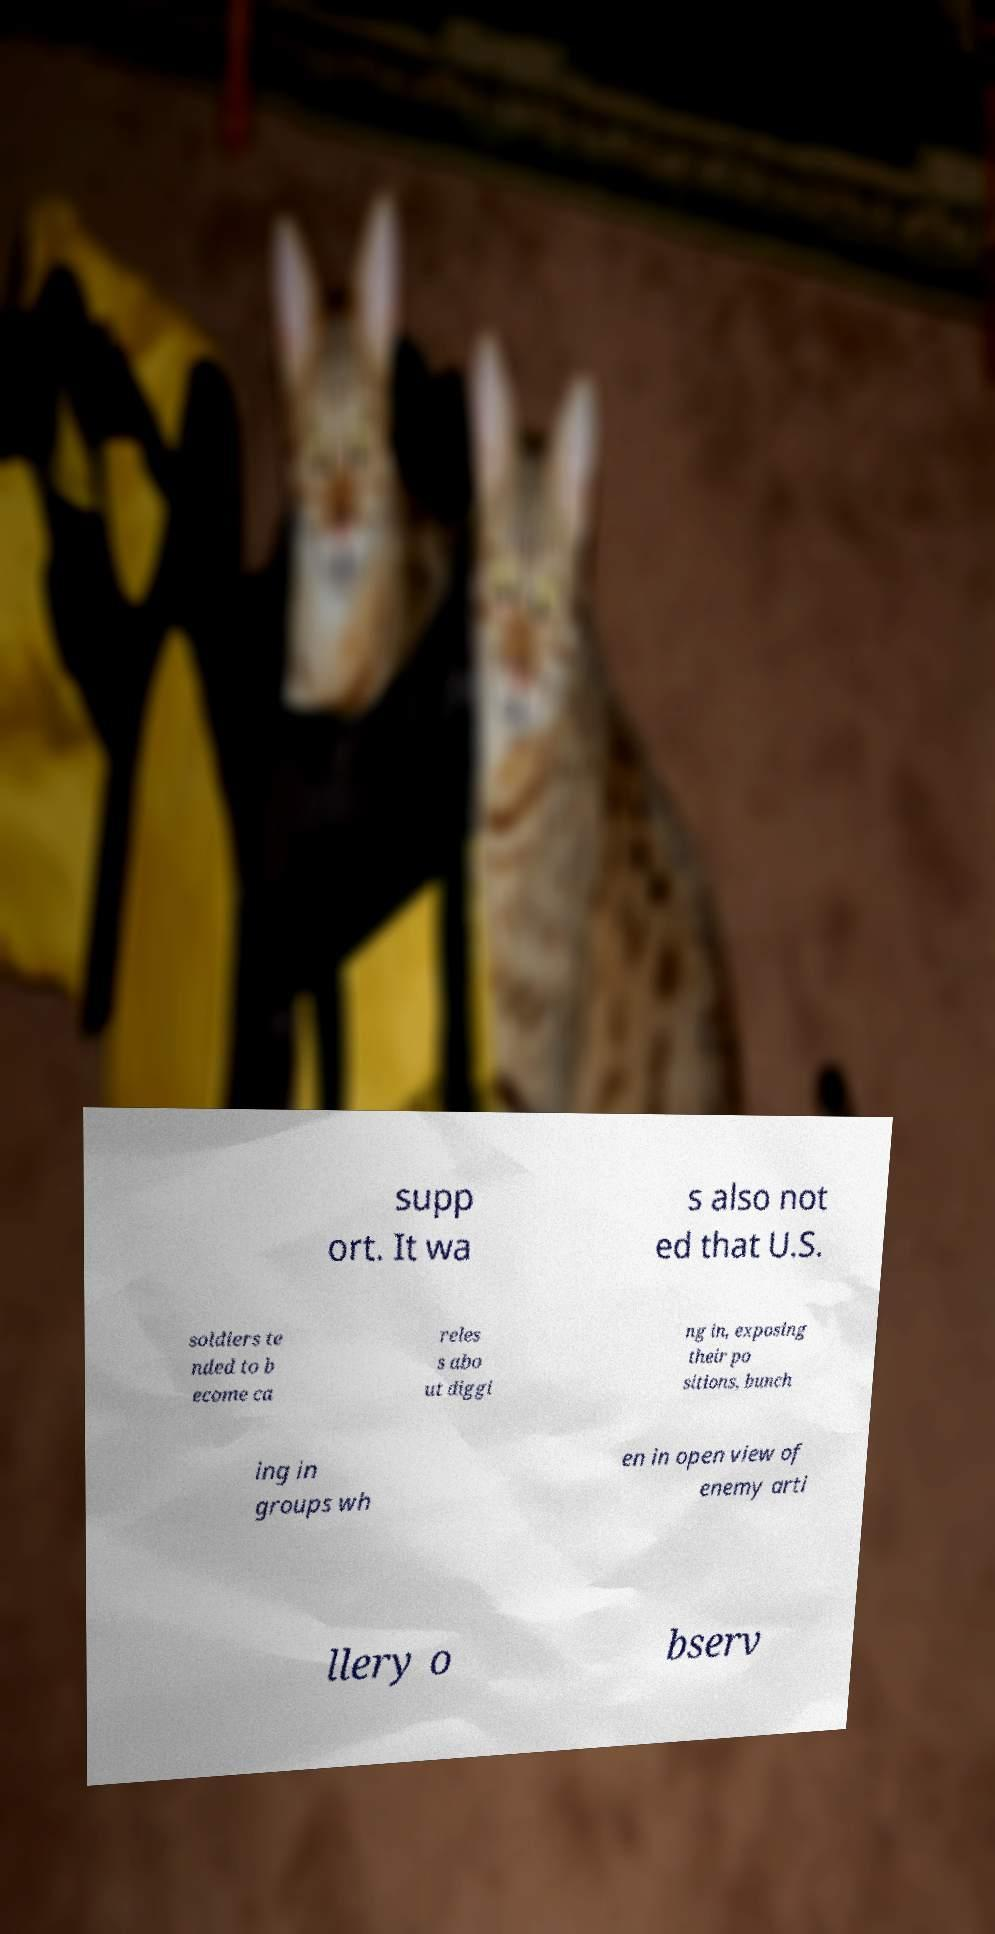There's text embedded in this image that I need extracted. Can you transcribe it verbatim? supp ort. It wa s also not ed that U.S. soldiers te nded to b ecome ca reles s abo ut diggi ng in, exposing their po sitions, bunch ing in groups wh en in open view of enemy arti llery o bserv 